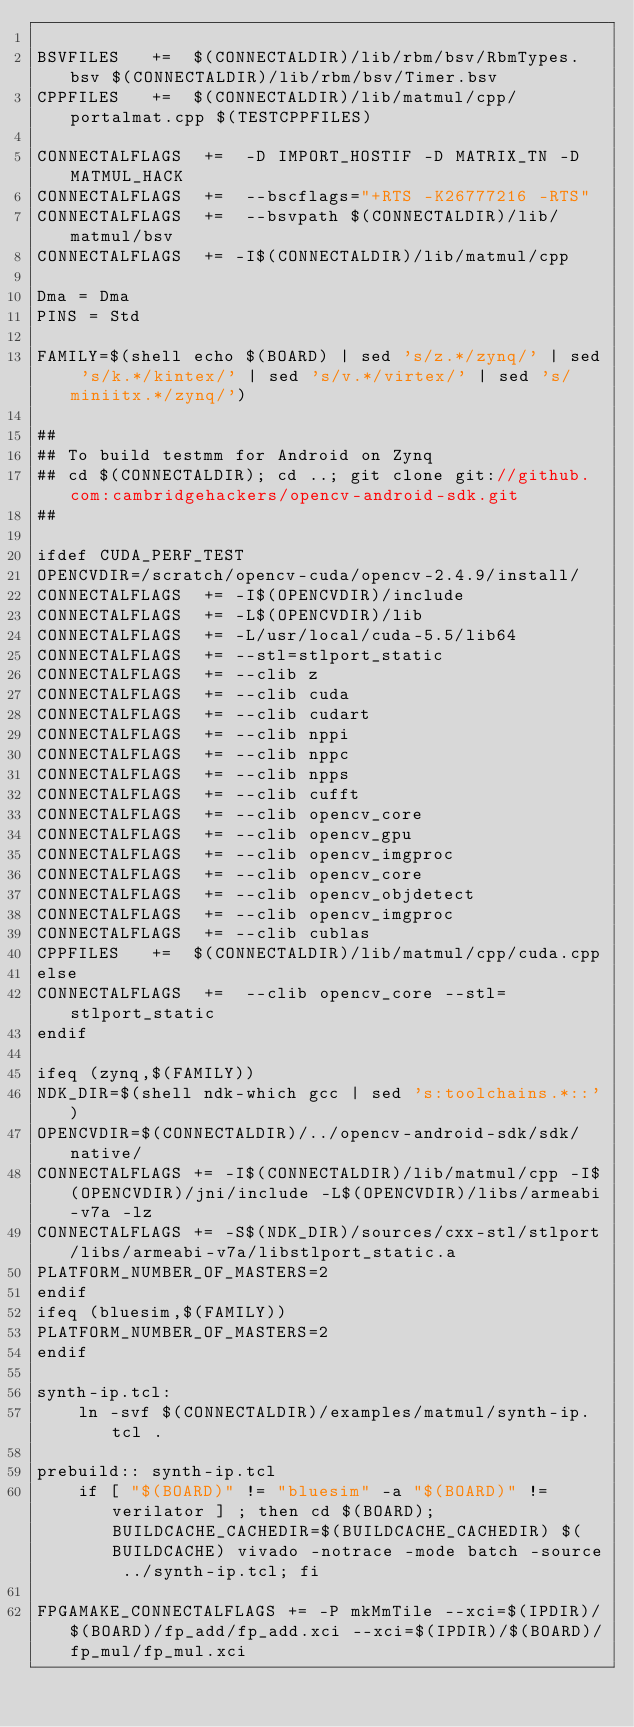Convert code to text. <code><loc_0><loc_0><loc_500><loc_500><_ObjectiveC_>
BSVFILES   +=  $(CONNECTALDIR)/lib/rbm/bsv/RbmTypes.bsv $(CONNECTALDIR)/lib/rbm/bsv/Timer.bsv
CPPFILES   +=  $(CONNECTALDIR)/lib/matmul/cpp/portalmat.cpp $(TESTCPPFILES)

CONNECTALFLAGS  +=  -D IMPORT_HOSTIF -D MATRIX_TN -D MATMUL_HACK
CONNECTALFLAGS  +=  --bscflags="+RTS -K26777216 -RTS"
CONNECTALFLAGS  +=  --bsvpath $(CONNECTALDIR)/lib/matmul/bsv
CONNECTALFLAGS  += -I$(CONNECTALDIR)/lib/matmul/cpp

Dma = Dma
PINS = Std

FAMILY=$(shell echo $(BOARD) | sed 's/z.*/zynq/' | sed 's/k.*/kintex/' | sed 's/v.*/virtex/' | sed 's/miniitx.*/zynq/')

##
## To build testmm for Android on Zynq
## cd $(CONNECTALDIR); cd ..; git clone git://github.com:cambridgehackers/opencv-android-sdk.git
##

ifdef CUDA_PERF_TEST
OPENCVDIR=/scratch/opencv-cuda/opencv-2.4.9/install/
CONNECTALFLAGS  += -I$(OPENCVDIR)/include
CONNECTALFLAGS  += -L$(OPENCVDIR)/lib
CONNECTALFLAGS  += -L/usr/local/cuda-5.5/lib64
CONNECTALFLAGS  += --stl=stlport_static
CONNECTALFLAGS  += --clib z
CONNECTALFLAGS  += --clib cuda
CONNECTALFLAGS  += --clib cudart
CONNECTALFLAGS  += --clib nppi
CONNECTALFLAGS  += --clib nppc
CONNECTALFLAGS  += --clib npps
CONNECTALFLAGS  += --clib cufft
CONNECTALFLAGS  += --clib opencv_core
CONNECTALFLAGS  += --clib opencv_gpu
CONNECTALFLAGS  += --clib opencv_imgproc
CONNECTALFLAGS  += --clib opencv_core
CONNECTALFLAGS  += --clib opencv_objdetect
CONNECTALFLAGS  += --clib opencv_imgproc
CONNECTALFLAGS  += --clib cublas
CPPFILES   +=  $(CONNECTALDIR)/lib/matmul/cpp/cuda.cpp 
else
CONNECTALFLAGS  +=  --clib opencv_core --stl=stlport_static
endif

ifeq (zynq,$(FAMILY))
NDK_DIR=$(shell ndk-which gcc | sed 's:toolchains.*::')
OPENCVDIR=$(CONNECTALDIR)/../opencv-android-sdk/sdk/native/
CONNECTALFLAGS += -I$(CONNECTALDIR)/lib/matmul/cpp -I$(OPENCVDIR)/jni/include -L$(OPENCVDIR)/libs/armeabi-v7a -lz
CONNECTALFLAGS += -S$(NDK_DIR)/sources/cxx-stl/stlport/libs/armeabi-v7a/libstlport_static.a
PLATFORM_NUMBER_OF_MASTERS=2
endif
ifeq (bluesim,$(FAMILY))
PLATFORM_NUMBER_OF_MASTERS=2
endif

synth-ip.tcl:
	ln -svf $(CONNECTALDIR)/examples/matmul/synth-ip.tcl .

prebuild:: synth-ip.tcl
	if [ "$(BOARD)" != "bluesim" -a "$(BOARD)" != verilator ] ; then cd $(BOARD); BUILDCACHE_CACHEDIR=$(BUILDCACHE_CACHEDIR) $(BUILDCACHE) vivado -notrace -mode batch -source ../synth-ip.tcl; fi

FPGAMAKE_CONNECTALFLAGS += -P mkMmTile --xci=$(IPDIR)/$(BOARD)/fp_add/fp_add.xci --xci=$(IPDIR)/$(BOARD)/fp_mul/fp_mul.xci

</code> 